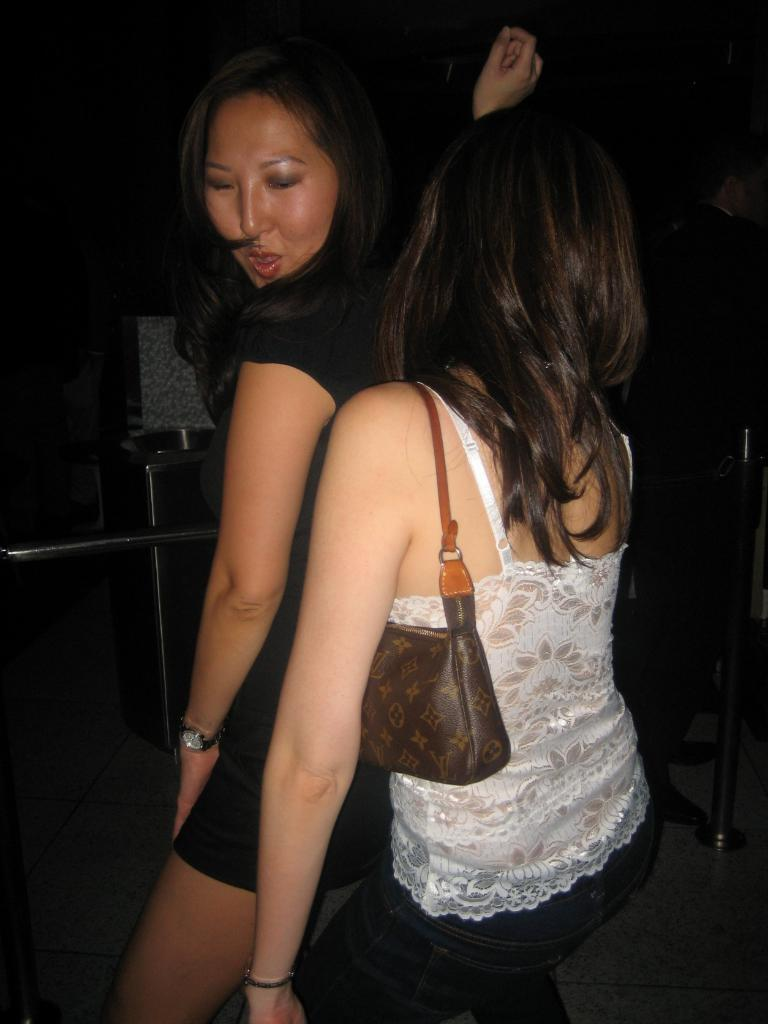How many girls are present in the image? There are two girls in the image. Where are the girls located in the image? The girls are at the center of the image. What are the girls doing in the image? The girls are dancing together. What type of cherries are being weighed on the scale in the image? There is no scale or cherries present in the image; it features two girls dancing together. What is the girls' state of mind while dancing in the image? The provided facts do not give information about the girls' state of mind while dancing. 